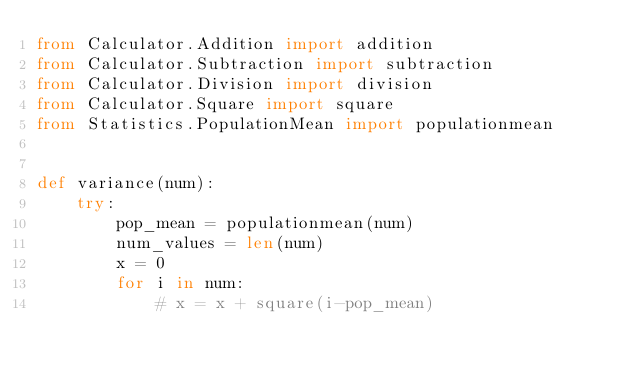<code> <loc_0><loc_0><loc_500><loc_500><_Python_>from Calculator.Addition import addition
from Calculator.Subtraction import subtraction
from Calculator.Division import division
from Calculator.Square import square
from Statistics.PopulationMean import populationmean


def variance(num):
    try:
        pop_mean = populationmean(num)
        num_values = len(num)
        x = 0
        for i in num:
            # x = x + square(i-pop_mean)</code> 